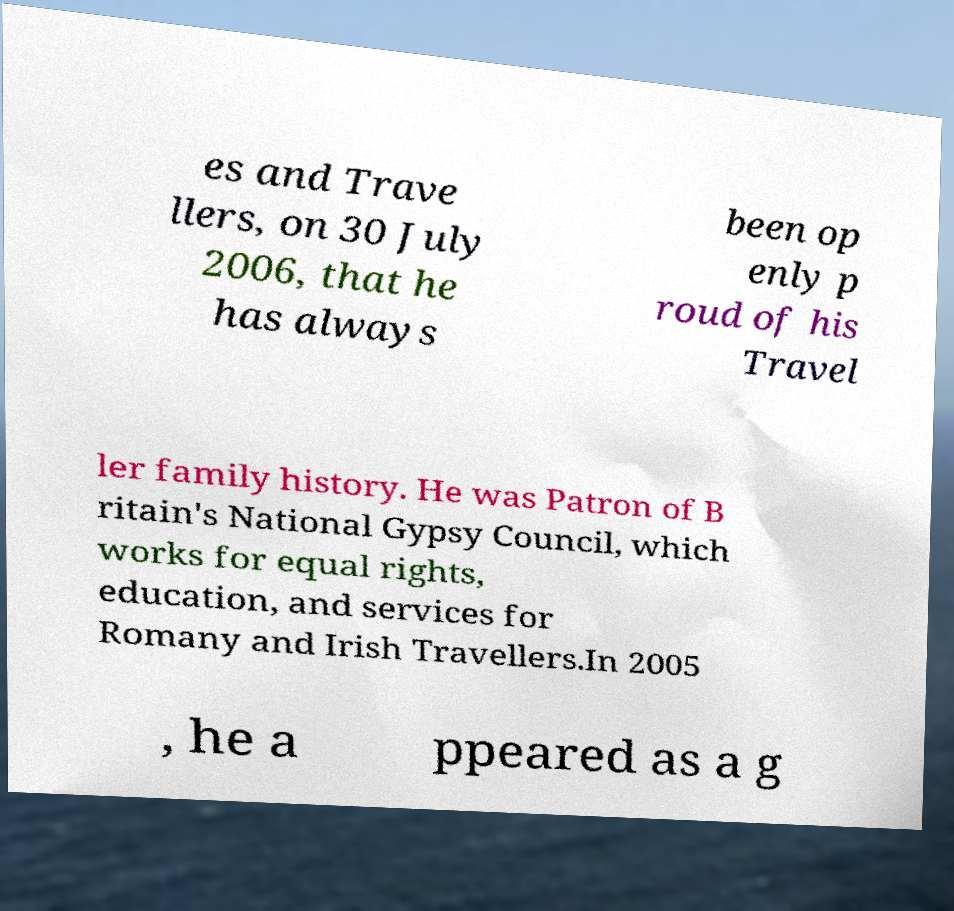There's text embedded in this image that I need extracted. Can you transcribe it verbatim? es and Trave llers, on 30 July 2006, that he has always been op enly p roud of his Travel ler family history. He was Patron of B ritain's National Gypsy Council, which works for equal rights, education, and services for Romany and Irish Travellers.In 2005 , he a ppeared as a g 